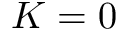Convert formula to latex. <formula><loc_0><loc_0><loc_500><loc_500>K = 0</formula> 